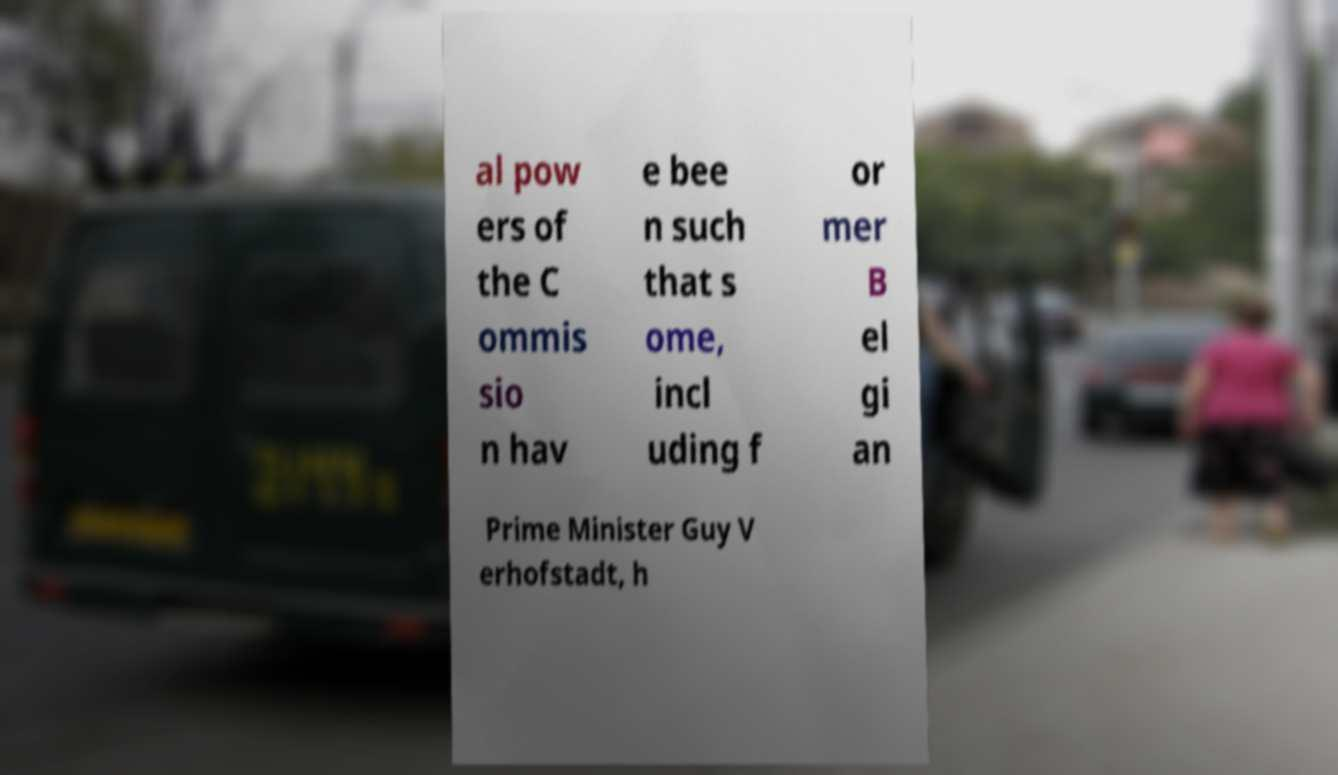Can you accurately transcribe the text from the provided image for me? al pow ers of the C ommis sio n hav e bee n such that s ome, incl uding f or mer B el gi an Prime Minister Guy V erhofstadt, h 